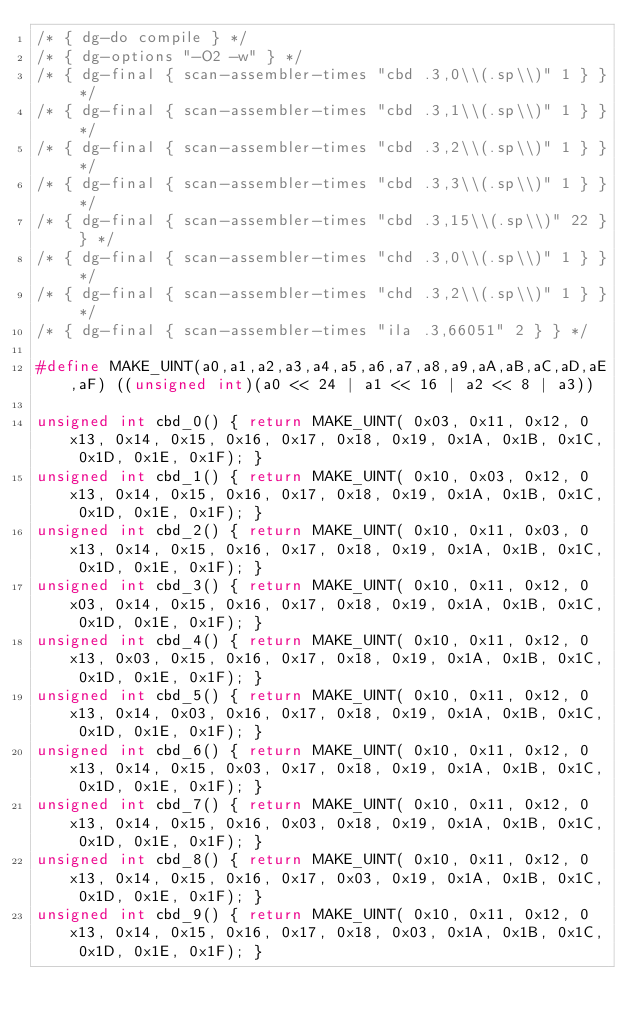<code> <loc_0><loc_0><loc_500><loc_500><_C_>/* { dg-do compile } */
/* { dg-options "-O2 -w" } */
/* { dg-final { scan-assembler-times "cbd	.3,0\\(.sp\\)" 1 } } */
/* { dg-final { scan-assembler-times "cbd	.3,1\\(.sp\\)" 1 } } */
/* { dg-final { scan-assembler-times "cbd	.3,2\\(.sp\\)" 1 } } */
/* { dg-final { scan-assembler-times "cbd	.3,3\\(.sp\\)" 1 } } */
/* { dg-final { scan-assembler-times "cbd	.3,15\\(.sp\\)" 22 } } */
/* { dg-final { scan-assembler-times "chd	.3,0\\(.sp\\)" 1 } } */
/* { dg-final { scan-assembler-times "chd	.3,2\\(.sp\\)" 1 } } */
/* { dg-final { scan-assembler-times "ila	.3,66051" 2 } } */

#define MAKE_UINT(a0,a1,a2,a3,a4,a5,a6,a7,a8,a9,aA,aB,aC,aD,aE,aF) ((unsigned int)(a0 << 24 | a1 << 16 | a2 << 8 | a3))

unsigned int cbd_0() { return MAKE_UINT( 0x03, 0x11, 0x12, 0x13, 0x14, 0x15, 0x16, 0x17, 0x18, 0x19, 0x1A, 0x1B, 0x1C, 0x1D, 0x1E, 0x1F); }
unsigned int cbd_1() { return MAKE_UINT( 0x10, 0x03, 0x12, 0x13, 0x14, 0x15, 0x16, 0x17, 0x18, 0x19, 0x1A, 0x1B, 0x1C, 0x1D, 0x1E, 0x1F); }
unsigned int cbd_2() { return MAKE_UINT( 0x10, 0x11, 0x03, 0x13, 0x14, 0x15, 0x16, 0x17, 0x18, 0x19, 0x1A, 0x1B, 0x1C, 0x1D, 0x1E, 0x1F); }
unsigned int cbd_3() { return MAKE_UINT( 0x10, 0x11, 0x12, 0x03, 0x14, 0x15, 0x16, 0x17, 0x18, 0x19, 0x1A, 0x1B, 0x1C, 0x1D, 0x1E, 0x1F); }
unsigned int cbd_4() { return MAKE_UINT( 0x10, 0x11, 0x12, 0x13, 0x03, 0x15, 0x16, 0x17, 0x18, 0x19, 0x1A, 0x1B, 0x1C, 0x1D, 0x1E, 0x1F); }
unsigned int cbd_5() { return MAKE_UINT( 0x10, 0x11, 0x12, 0x13, 0x14, 0x03, 0x16, 0x17, 0x18, 0x19, 0x1A, 0x1B, 0x1C, 0x1D, 0x1E, 0x1F); }
unsigned int cbd_6() { return MAKE_UINT( 0x10, 0x11, 0x12, 0x13, 0x14, 0x15, 0x03, 0x17, 0x18, 0x19, 0x1A, 0x1B, 0x1C, 0x1D, 0x1E, 0x1F); }
unsigned int cbd_7() { return MAKE_UINT( 0x10, 0x11, 0x12, 0x13, 0x14, 0x15, 0x16, 0x03, 0x18, 0x19, 0x1A, 0x1B, 0x1C, 0x1D, 0x1E, 0x1F); }
unsigned int cbd_8() { return MAKE_UINT( 0x10, 0x11, 0x12, 0x13, 0x14, 0x15, 0x16, 0x17, 0x03, 0x19, 0x1A, 0x1B, 0x1C, 0x1D, 0x1E, 0x1F); }
unsigned int cbd_9() { return MAKE_UINT( 0x10, 0x11, 0x12, 0x13, 0x14, 0x15, 0x16, 0x17, 0x18, 0x03, 0x1A, 0x1B, 0x1C, 0x1D, 0x1E, 0x1F); }</code> 